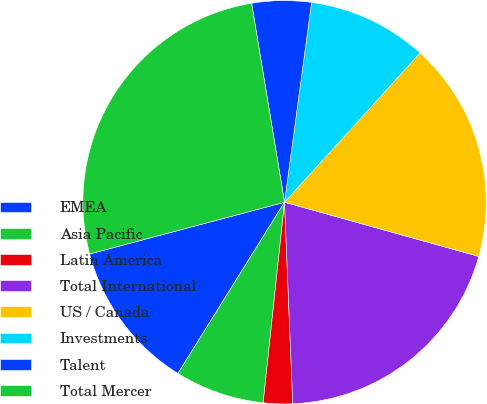<chart> <loc_0><loc_0><loc_500><loc_500><pie_chart><fcel>EMEA<fcel>Asia Pacific<fcel>Latin America<fcel>Total International<fcel>US / Canada<fcel>Investments<fcel>Talent<fcel>Total Mercer<nl><fcel>12.01%<fcel>7.17%<fcel>2.34%<fcel>20.02%<fcel>17.6%<fcel>9.59%<fcel>4.75%<fcel>26.52%<nl></chart> 